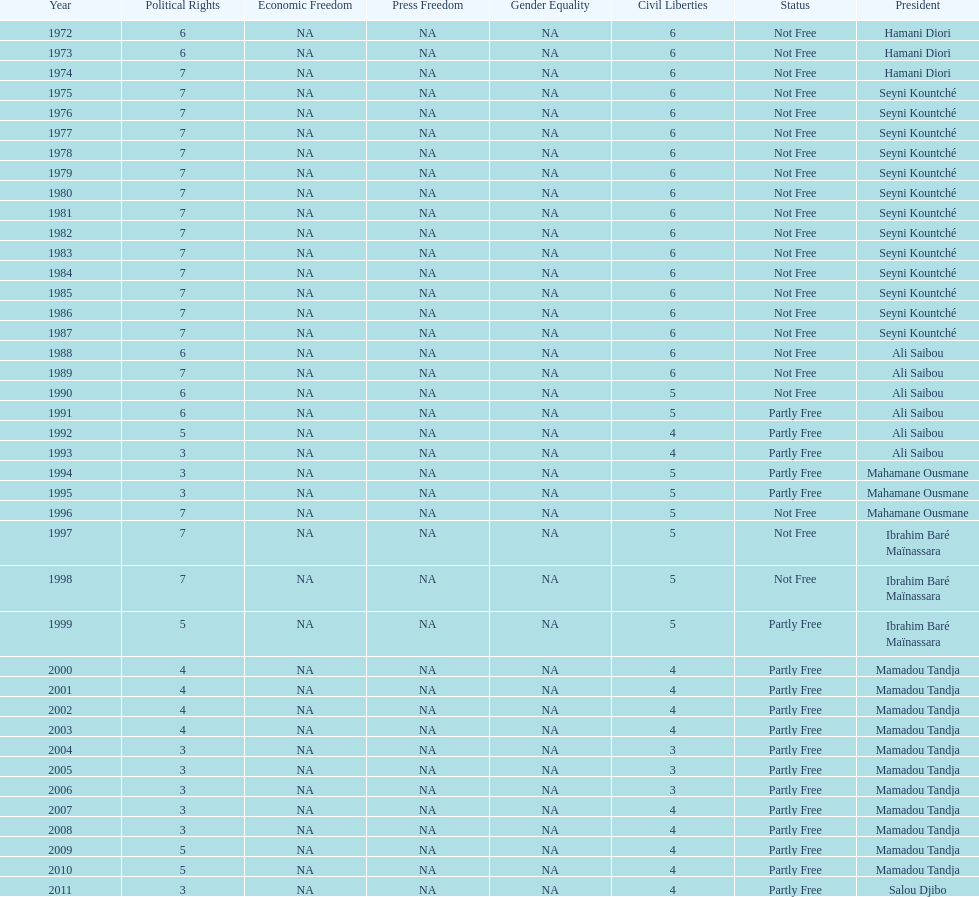Who was president before mamadou tandja? Ibrahim Baré Maïnassara. 